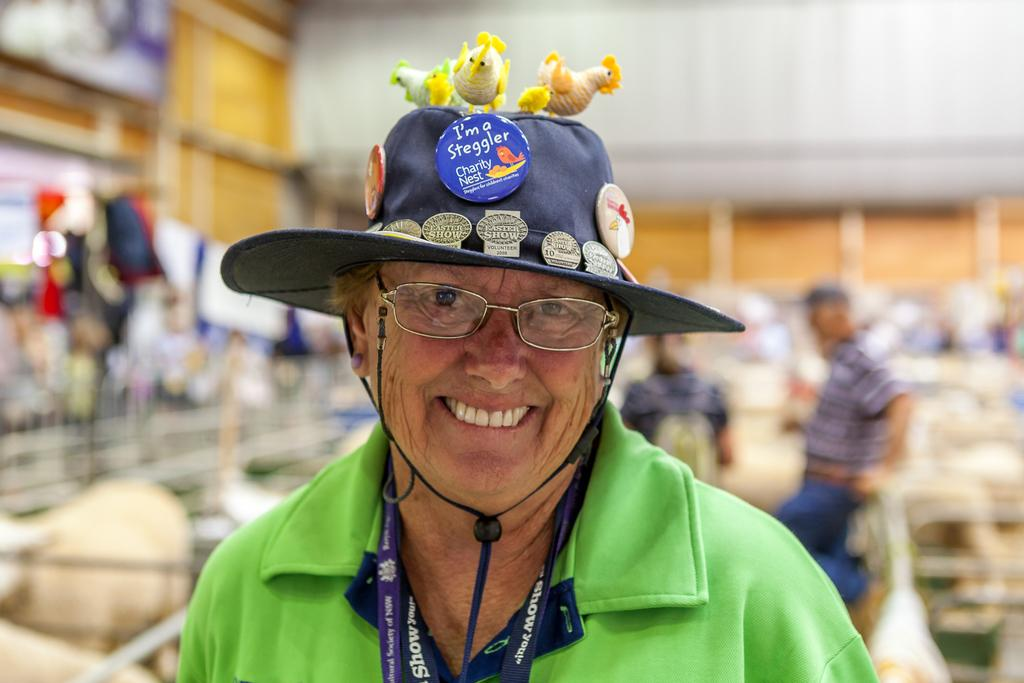Who is the main subject in the image? There is a lady in the center of the image. What is the lady wearing on her head? The lady is wearing a hat. What can be seen in the background of the image? There are other people and racks in the background of the image. How are the background elements depicted? The background elements are blurred. What type of fog can be seen in the image? There is no fog present in the image. What achievements has the yard been recognized for in the image? There is no yard or achiever mentioned in the image; it features a lady wearing a hat with other people and racks in the background. 